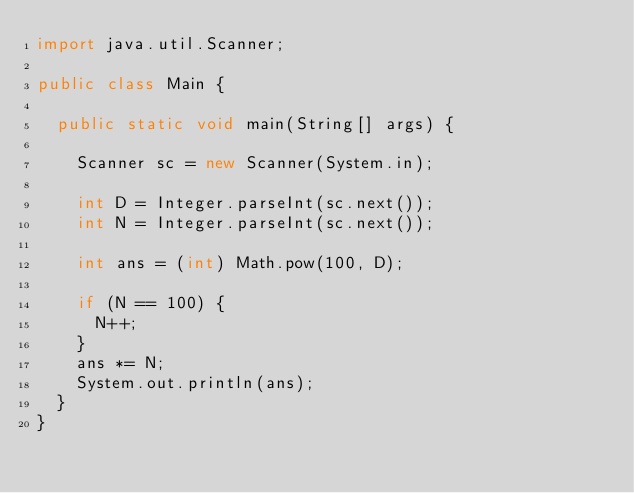<code> <loc_0><loc_0><loc_500><loc_500><_Java_>import java.util.Scanner;

public class Main {

  public static void main(String[] args) {

    Scanner sc = new Scanner(System.in);

    int D = Integer.parseInt(sc.next());
    int N = Integer.parseInt(sc.next());

    int ans = (int) Math.pow(100, D);

    if (N == 100) {
      N++;
    }
    ans *= N;
    System.out.println(ans);
  }
}</code> 